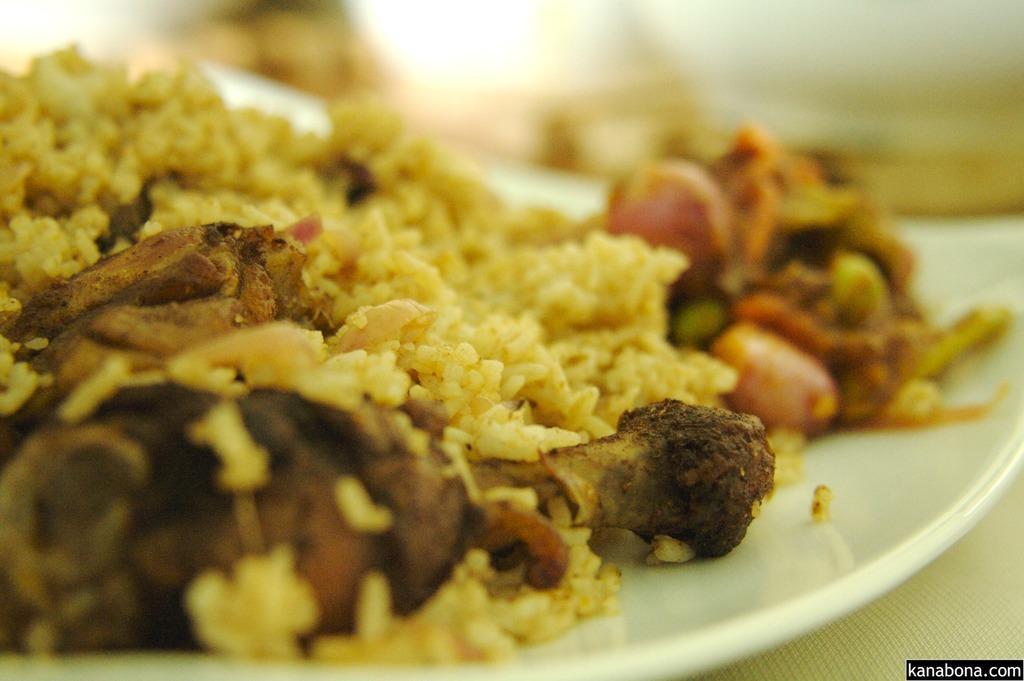Could you give a brief overview of what you see in this image? In this image there is food on the plate, there is a plate on the surface, there is text towards the bottom of the image, there is food truncated towards the left of the image, the background of the image is blurred. 